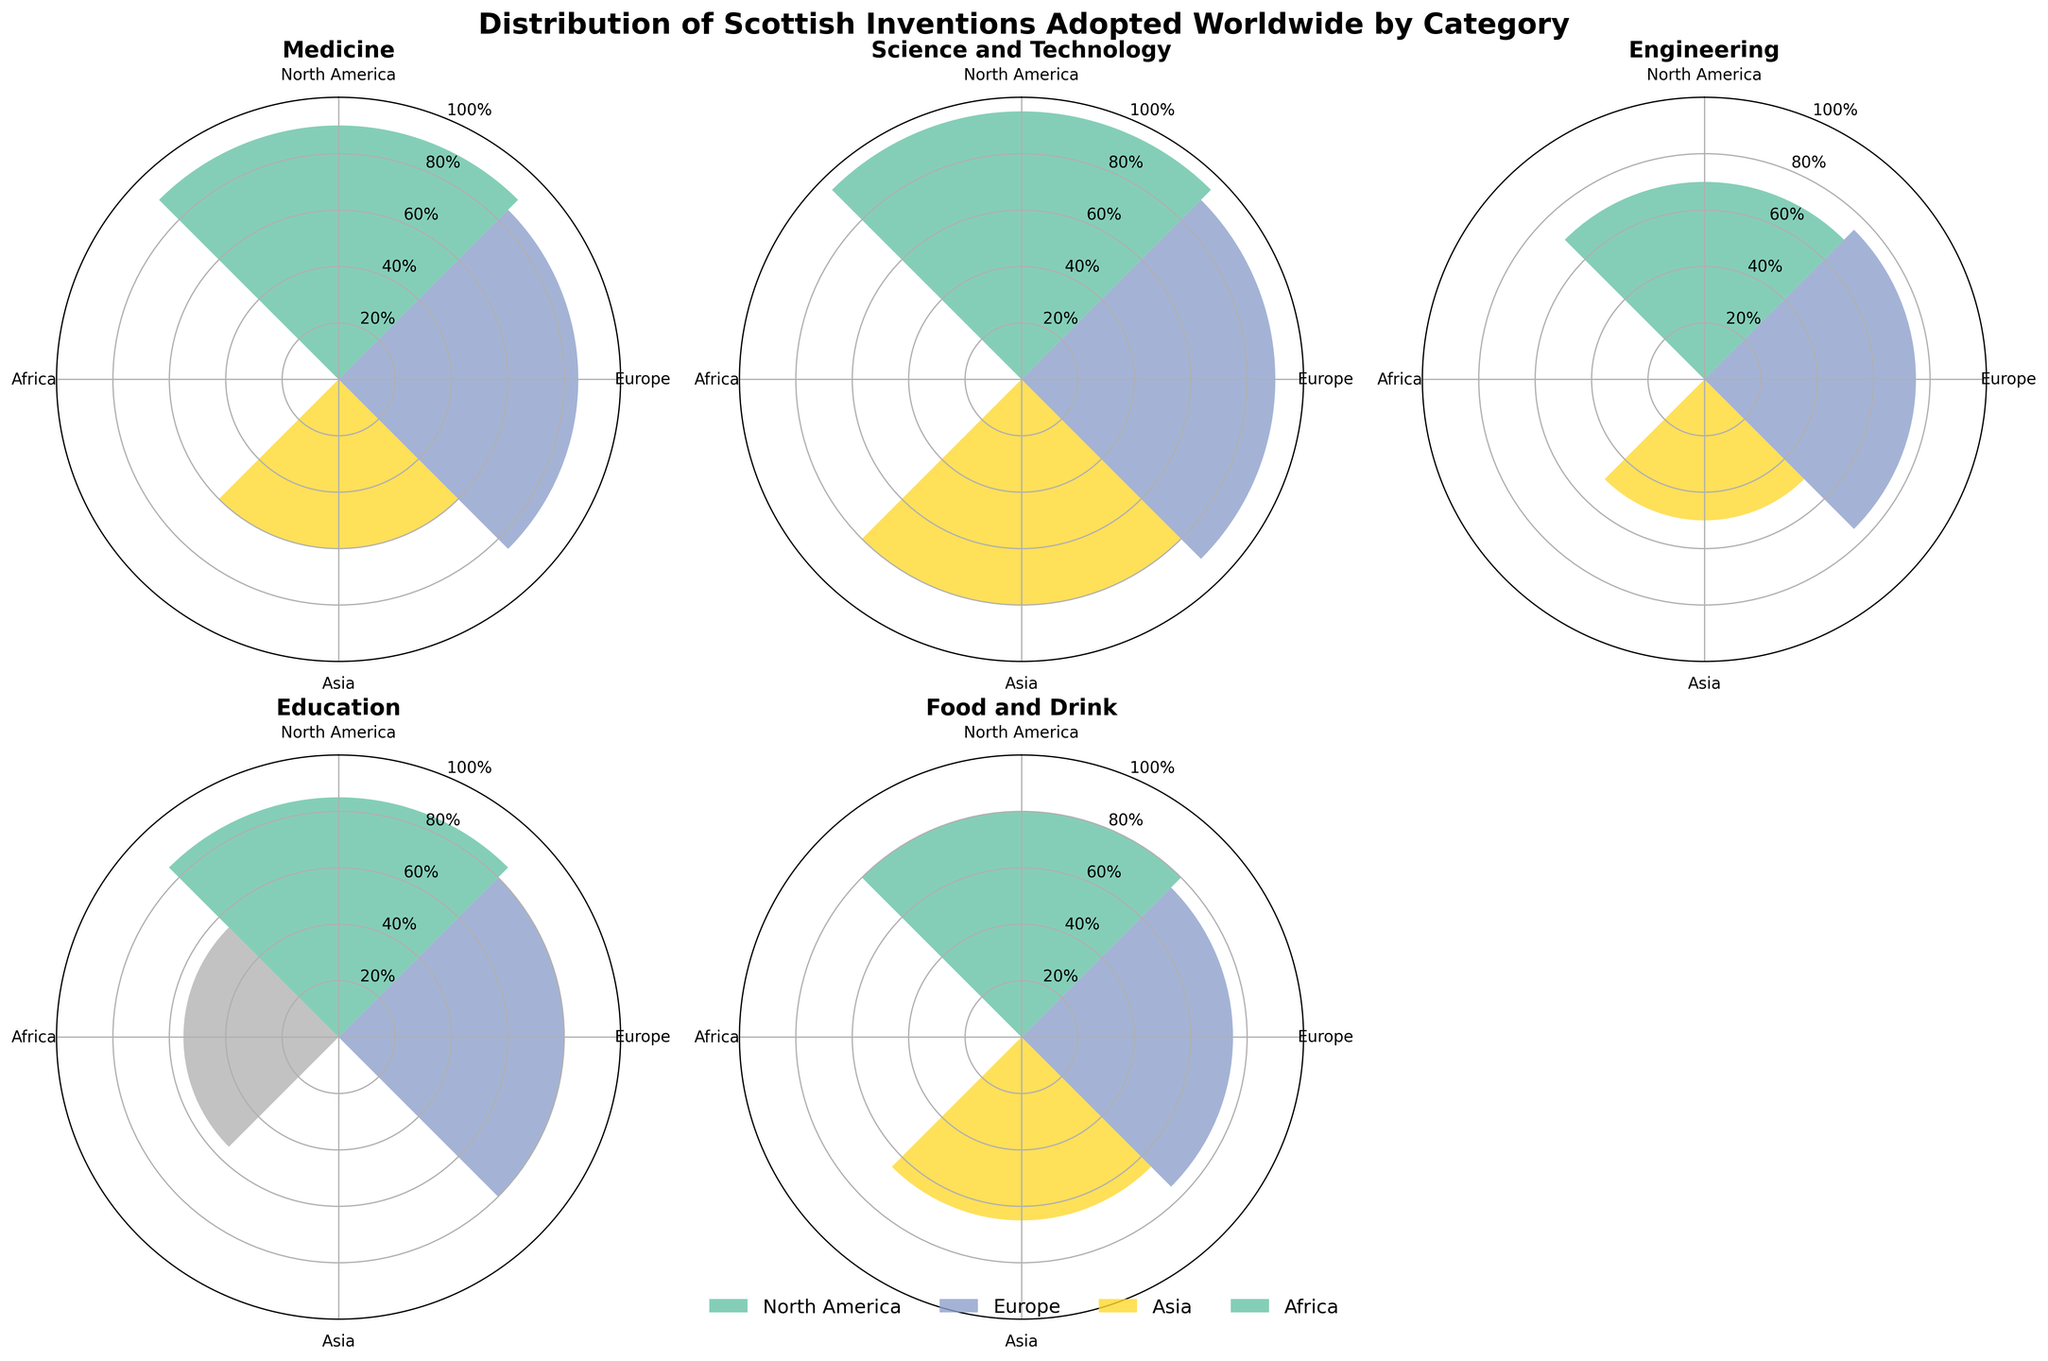What is the title of the figure? The title of the figure is mentioned at the top.
Answer: Distribution of Scottish Inventions Adopted Worldwide by Category Which region shows the highest adoption rate for Penicillin? By observing the medicine subplot for Penicillin, the highest bar should correspond to the region with the highest adoption rate.
Answer: North America How does the adoption rate of the Telephone in Asia compare to Europe? Look at the Science and Technology subplot and compare the bar heights for Asia and Europe. Asia has a rate of 80%, and Europe has a rate of 90%.
Answer: Asia's adoption rate is 10% lower than Europe's What is the average adoption rate for the Steam Engine across all regions? The adoption rates for the Steam Engine are 70% (North America), 75% (Europe), and 50% (Asia). Compute the average by summing these values and dividing by the number of regions. (70 + 75 + 50) / 3 = 195 / 3 = 65.
Answer: 65% Compare the adoption rates of Whisky in North America and Asia. In the Food and Drink subplot, compare the bars for North America and Asia. North America has an adoption rate of 80%, and Asia has 65%.
Answer: North America's rate is 15% higher than Asia's What is the adoption rate of the Modern University System in Africa? Look at the Education subplot and identify the bar corresponding to Africa.
Answer: 55% Which categories show higher adoption rates in Europe than North America? Compare the bars for Europe and North America across the different subplots. There is no category where Europe's rate exceeds North America's.
Answer: None How many categories have an adoption rate of 75% or higher in Europe? Look at each subplot and count the categories where Europe's bar is 75% or higher (Penicillin, Telephone, Steam Engine, Whisky). There are four such instances.
Answer: 4 Which invention shows the lowest adoption rate overall in any region? Scan across all subplots and find the smallest bar. The smallest rate is for the Steam Engine in Asia at 50%.
Answer: Steam Engine in Asia What is the sum of adoption rates for Penicillin in all regions? The adoption rates for Penicillin are 90% (North America), 85% (Europe), and 60% (Asia). Sum these values: 90 + 85 + 60 = 235.
Answer: 235% 